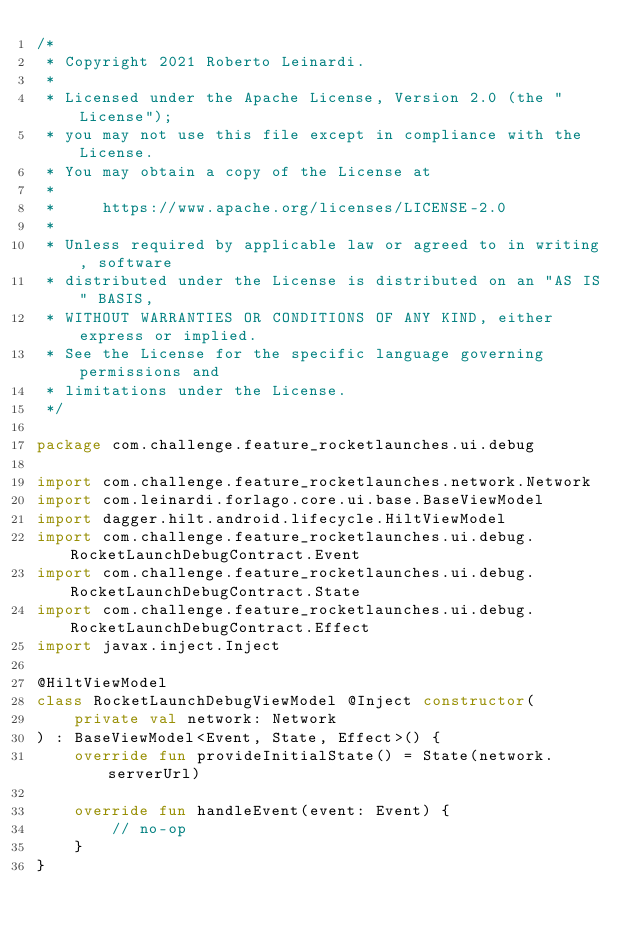<code> <loc_0><loc_0><loc_500><loc_500><_Kotlin_>/*
 * Copyright 2021 Roberto Leinardi.
 *
 * Licensed under the Apache License, Version 2.0 (the "License");
 * you may not use this file except in compliance with the License.
 * You may obtain a copy of the License at
 *
 *     https://www.apache.org/licenses/LICENSE-2.0
 *
 * Unless required by applicable law or agreed to in writing, software
 * distributed under the License is distributed on an "AS IS" BASIS,
 * WITHOUT WARRANTIES OR CONDITIONS OF ANY KIND, either express or implied.
 * See the License for the specific language governing permissions and
 * limitations under the License.
 */

package com.challenge.feature_rocketlaunches.ui.debug

import com.challenge.feature_rocketlaunches.network.Network
import com.leinardi.forlago.core.ui.base.BaseViewModel
import dagger.hilt.android.lifecycle.HiltViewModel
import com.challenge.feature_rocketlaunches.ui.debug.RocketLaunchDebugContract.Event
import com.challenge.feature_rocketlaunches.ui.debug.RocketLaunchDebugContract.State
import com.challenge.feature_rocketlaunches.ui.debug.RocketLaunchDebugContract.Effect
import javax.inject.Inject

@HiltViewModel
class RocketLaunchDebugViewModel @Inject constructor(
    private val network: Network
) : BaseViewModel<Event, State, Effect>() {
    override fun provideInitialState() = State(network.serverUrl)

    override fun handleEvent(event: Event) {
        // no-op
    }
}</code> 